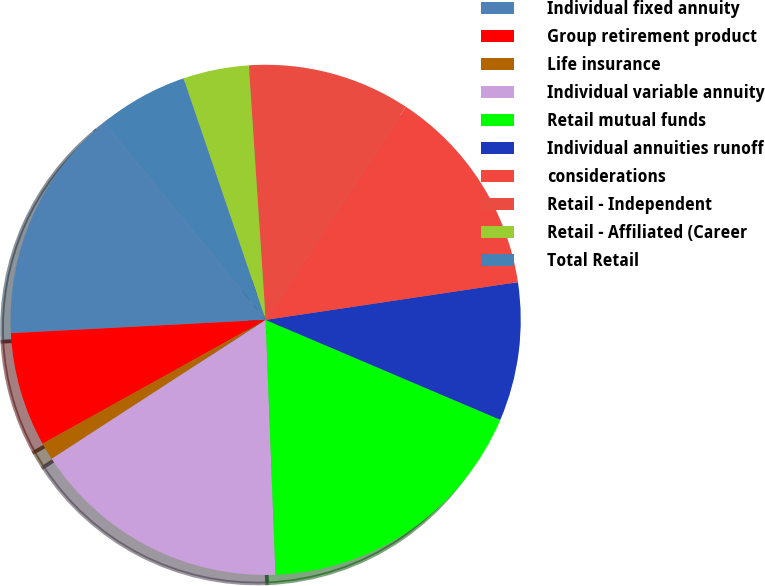Convert chart. <chart><loc_0><loc_0><loc_500><loc_500><pie_chart><fcel>Individual fixed annuity<fcel>Group retirement product<fcel>Life insurance<fcel>Individual variable annuity<fcel>Retail mutual funds<fcel>Individual annuities runoff<fcel>considerations<fcel>Retail - Independent<fcel>Retail - Affiliated (Career<fcel>Total Retail<nl><fcel>14.91%<fcel>7.24%<fcel>1.1%<fcel>16.45%<fcel>17.98%<fcel>8.77%<fcel>13.38%<fcel>10.31%<fcel>4.17%<fcel>5.7%<nl></chart> 